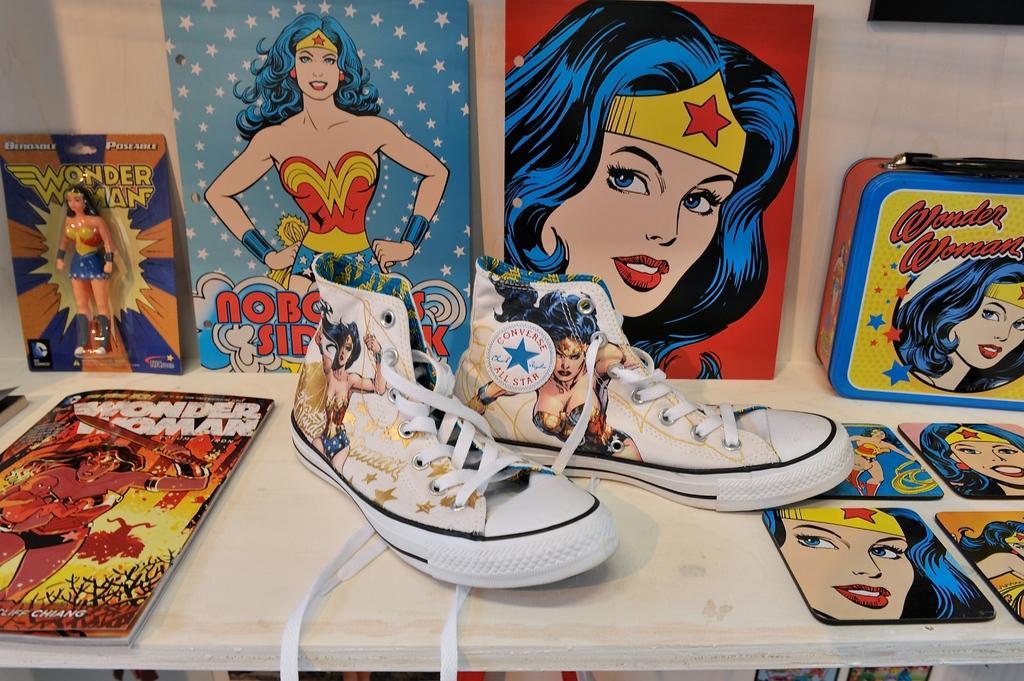In one or two sentences, can you explain what this image depicts? In this image there is a pair of shoes, books and a box arranged on the shelf. 